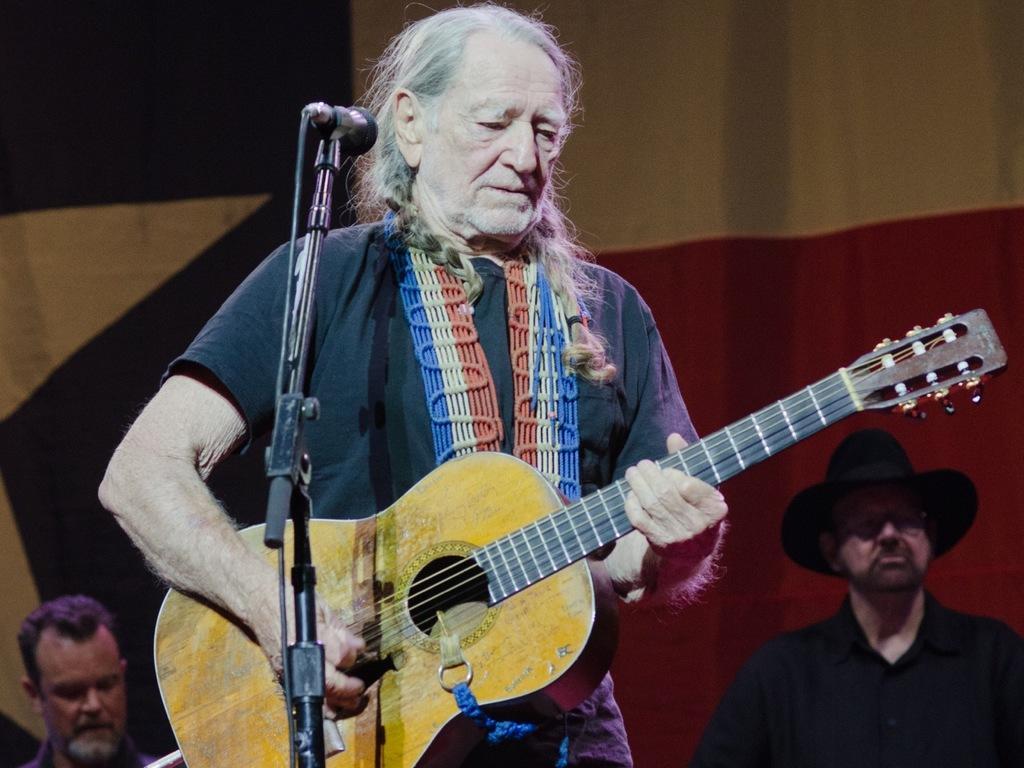How would you summarize this image in a sentence or two? In the image we can see there is a man who is standing and holding guitar in his hand. At the back there are people standing. 